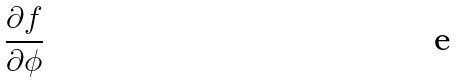Convert formula to latex. <formula><loc_0><loc_0><loc_500><loc_500>\frac { \partial f } { \partial \phi }</formula> 